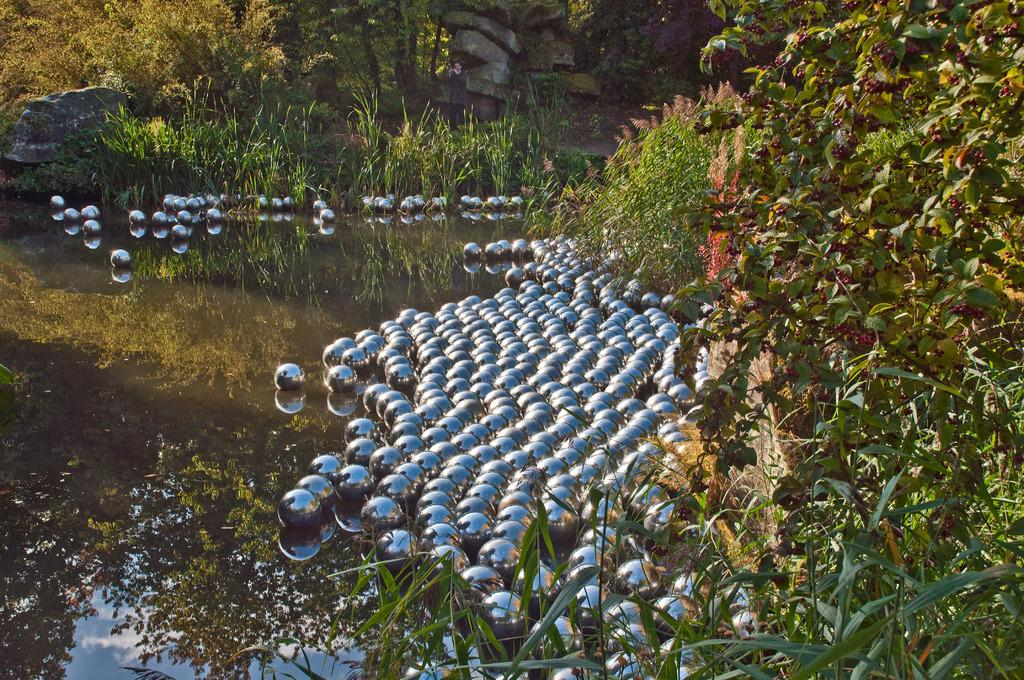What is visible in the image? Water, balls, plants, trees, and rocks are visible in the image. Can you describe the type of environment depicted in the image? The image features a natural environment with water, plants, and trees. What objects are present in the image that are not part of the natural environment? Balls are present in the image that are not part of the natural environment. What type of hearing device can be seen in the image? There is no hearing device present in the image. Is there any eggnog visible in the image? There is no eggnog present in the image. 